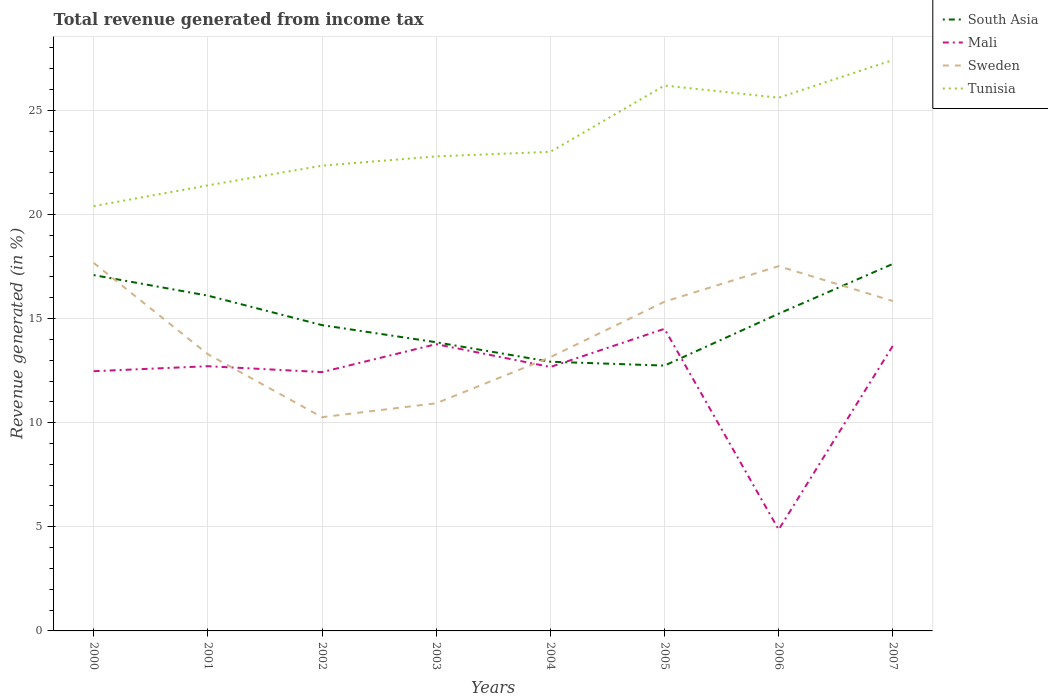Is the number of lines equal to the number of legend labels?
Keep it short and to the point. Yes. Across all years, what is the maximum total revenue generated in Sweden?
Make the answer very short. 10.26. What is the total total revenue generated in Tunisia in the graph?
Your answer should be compact. -1.81. What is the difference between the highest and the second highest total revenue generated in Mali?
Your response must be concise. 9.64. Is the total revenue generated in Tunisia strictly greater than the total revenue generated in Mali over the years?
Your answer should be very brief. No. How many lines are there?
Ensure brevity in your answer.  4. How many years are there in the graph?
Offer a very short reply. 8. What is the difference between two consecutive major ticks on the Y-axis?
Your answer should be compact. 5. Are the values on the major ticks of Y-axis written in scientific E-notation?
Offer a very short reply. No. Does the graph contain any zero values?
Ensure brevity in your answer.  No. Where does the legend appear in the graph?
Keep it short and to the point. Top right. What is the title of the graph?
Offer a terse response. Total revenue generated from income tax. Does "Spain" appear as one of the legend labels in the graph?
Keep it short and to the point. No. What is the label or title of the X-axis?
Ensure brevity in your answer.  Years. What is the label or title of the Y-axis?
Ensure brevity in your answer.  Revenue generated (in %). What is the Revenue generated (in %) of South Asia in 2000?
Your answer should be compact. 17.09. What is the Revenue generated (in %) of Mali in 2000?
Give a very brief answer. 12.47. What is the Revenue generated (in %) in Sweden in 2000?
Provide a succinct answer. 17.67. What is the Revenue generated (in %) of Tunisia in 2000?
Keep it short and to the point. 20.4. What is the Revenue generated (in %) of South Asia in 2001?
Offer a very short reply. 16.1. What is the Revenue generated (in %) of Mali in 2001?
Your answer should be very brief. 12.71. What is the Revenue generated (in %) in Sweden in 2001?
Provide a succinct answer. 13.29. What is the Revenue generated (in %) in Tunisia in 2001?
Make the answer very short. 21.39. What is the Revenue generated (in %) of South Asia in 2002?
Give a very brief answer. 14.68. What is the Revenue generated (in %) in Mali in 2002?
Make the answer very short. 12.43. What is the Revenue generated (in %) in Sweden in 2002?
Your answer should be very brief. 10.26. What is the Revenue generated (in %) of Tunisia in 2002?
Your response must be concise. 22.34. What is the Revenue generated (in %) of South Asia in 2003?
Ensure brevity in your answer.  13.86. What is the Revenue generated (in %) of Mali in 2003?
Give a very brief answer. 13.77. What is the Revenue generated (in %) in Sweden in 2003?
Give a very brief answer. 10.93. What is the Revenue generated (in %) of Tunisia in 2003?
Your answer should be very brief. 22.79. What is the Revenue generated (in %) of South Asia in 2004?
Make the answer very short. 12.93. What is the Revenue generated (in %) of Mali in 2004?
Provide a succinct answer. 12.67. What is the Revenue generated (in %) in Sweden in 2004?
Your answer should be very brief. 13.14. What is the Revenue generated (in %) in Tunisia in 2004?
Offer a very short reply. 23.01. What is the Revenue generated (in %) in South Asia in 2005?
Your answer should be compact. 12.74. What is the Revenue generated (in %) in Mali in 2005?
Offer a very short reply. 14.51. What is the Revenue generated (in %) of Sweden in 2005?
Your answer should be compact. 15.81. What is the Revenue generated (in %) in Tunisia in 2005?
Keep it short and to the point. 26.19. What is the Revenue generated (in %) in South Asia in 2006?
Ensure brevity in your answer.  15.23. What is the Revenue generated (in %) in Mali in 2006?
Provide a succinct answer. 4.87. What is the Revenue generated (in %) of Sweden in 2006?
Make the answer very short. 17.52. What is the Revenue generated (in %) in Tunisia in 2006?
Ensure brevity in your answer.  25.61. What is the Revenue generated (in %) of South Asia in 2007?
Make the answer very short. 17.62. What is the Revenue generated (in %) of Mali in 2007?
Offer a terse response. 13.69. What is the Revenue generated (in %) in Sweden in 2007?
Give a very brief answer. 15.84. What is the Revenue generated (in %) of Tunisia in 2007?
Give a very brief answer. 27.41. Across all years, what is the maximum Revenue generated (in %) in South Asia?
Ensure brevity in your answer.  17.62. Across all years, what is the maximum Revenue generated (in %) in Mali?
Provide a succinct answer. 14.51. Across all years, what is the maximum Revenue generated (in %) of Sweden?
Provide a short and direct response. 17.67. Across all years, what is the maximum Revenue generated (in %) of Tunisia?
Keep it short and to the point. 27.41. Across all years, what is the minimum Revenue generated (in %) in South Asia?
Your answer should be compact. 12.74. Across all years, what is the minimum Revenue generated (in %) in Mali?
Offer a terse response. 4.87. Across all years, what is the minimum Revenue generated (in %) of Sweden?
Your answer should be very brief. 10.26. Across all years, what is the minimum Revenue generated (in %) of Tunisia?
Keep it short and to the point. 20.4. What is the total Revenue generated (in %) of South Asia in the graph?
Give a very brief answer. 120.26. What is the total Revenue generated (in %) of Mali in the graph?
Make the answer very short. 97.12. What is the total Revenue generated (in %) in Sweden in the graph?
Offer a very short reply. 114.47. What is the total Revenue generated (in %) in Tunisia in the graph?
Offer a terse response. 189.14. What is the difference between the Revenue generated (in %) of South Asia in 2000 and that in 2001?
Your answer should be compact. 0.99. What is the difference between the Revenue generated (in %) of Mali in 2000 and that in 2001?
Provide a short and direct response. -0.24. What is the difference between the Revenue generated (in %) in Sweden in 2000 and that in 2001?
Your response must be concise. 4.38. What is the difference between the Revenue generated (in %) in Tunisia in 2000 and that in 2001?
Keep it short and to the point. -0.99. What is the difference between the Revenue generated (in %) of South Asia in 2000 and that in 2002?
Your response must be concise. 2.4. What is the difference between the Revenue generated (in %) in Mali in 2000 and that in 2002?
Keep it short and to the point. 0.04. What is the difference between the Revenue generated (in %) in Sweden in 2000 and that in 2002?
Make the answer very short. 7.41. What is the difference between the Revenue generated (in %) of Tunisia in 2000 and that in 2002?
Offer a very short reply. -1.94. What is the difference between the Revenue generated (in %) of South Asia in 2000 and that in 2003?
Provide a succinct answer. 3.23. What is the difference between the Revenue generated (in %) of Mali in 2000 and that in 2003?
Provide a succinct answer. -1.3. What is the difference between the Revenue generated (in %) in Sweden in 2000 and that in 2003?
Your response must be concise. 6.74. What is the difference between the Revenue generated (in %) of Tunisia in 2000 and that in 2003?
Your response must be concise. -2.39. What is the difference between the Revenue generated (in %) of South Asia in 2000 and that in 2004?
Your answer should be very brief. 4.16. What is the difference between the Revenue generated (in %) in Mali in 2000 and that in 2004?
Give a very brief answer. -0.2. What is the difference between the Revenue generated (in %) of Sweden in 2000 and that in 2004?
Ensure brevity in your answer.  4.53. What is the difference between the Revenue generated (in %) in Tunisia in 2000 and that in 2004?
Provide a succinct answer. -2.6. What is the difference between the Revenue generated (in %) in South Asia in 2000 and that in 2005?
Your response must be concise. 4.35. What is the difference between the Revenue generated (in %) of Mali in 2000 and that in 2005?
Your answer should be compact. -2.04. What is the difference between the Revenue generated (in %) in Sweden in 2000 and that in 2005?
Provide a short and direct response. 1.86. What is the difference between the Revenue generated (in %) of Tunisia in 2000 and that in 2005?
Provide a succinct answer. -5.79. What is the difference between the Revenue generated (in %) of South Asia in 2000 and that in 2006?
Make the answer very short. 1.85. What is the difference between the Revenue generated (in %) in Mali in 2000 and that in 2006?
Make the answer very short. 7.61. What is the difference between the Revenue generated (in %) in Sweden in 2000 and that in 2006?
Provide a succinct answer. 0.16. What is the difference between the Revenue generated (in %) of Tunisia in 2000 and that in 2006?
Your answer should be compact. -5.2. What is the difference between the Revenue generated (in %) in South Asia in 2000 and that in 2007?
Make the answer very short. -0.54. What is the difference between the Revenue generated (in %) of Mali in 2000 and that in 2007?
Provide a succinct answer. -1.22. What is the difference between the Revenue generated (in %) in Sweden in 2000 and that in 2007?
Provide a succinct answer. 1.83. What is the difference between the Revenue generated (in %) in Tunisia in 2000 and that in 2007?
Give a very brief answer. -7.01. What is the difference between the Revenue generated (in %) of South Asia in 2001 and that in 2002?
Your answer should be compact. 1.42. What is the difference between the Revenue generated (in %) in Mali in 2001 and that in 2002?
Give a very brief answer. 0.28. What is the difference between the Revenue generated (in %) of Sweden in 2001 and that in 2002?
Give a very brief answer. 3.03. What is the difference between the Revenue generated (in %) of Tunisia in 2001 and that in 2002?
Ensure brevity in your answer.  -0.95. What is the difference between the Revenue generated (in %) of South Asia in 2001 and that in 2003?
Keep it short and to the point. 2.24. What is the difference between the Revenue generated (in %) of Mali in 2001 and that in 2003?
Ensure brevity in your answer.  -1.06. What is the difference between the Revenue generated (in %) of Sweden in 2001 and that in 2003?
Give a very brief answer. 2.36. What is the difference between the Revenue generated (in %) of Tunisia in 2001 and that in 2003?
Your answer should be very brief. -1.39. What is the difference between the Revenue generated (in %) of South Asia in 2001 and that in 2004?
Offer a very short reply. 3.17. What is the difference between the Revenue generated (in %) of Mali in 2001 and that in 2004?
Your answer should be very brief. 0.04. What is the difference between the Revenue generated (in %) of Sweden in 2001 and that in 2004?
Provide a succinct answer. 0.14. What is the difference between the Revenue generated (in %) of Tunisia in 2001 and that in 2004?
Give a very brief answer. -1.61. What is the difference between the Revenue generated (in %) of South Asia in 2001 and that in 2005?
Offer a terse response. 3.36. What is the difference between the Revenue generated (in %) of Mali in 2001 and that in 2005?
Give a very brief answer. -1.8. What is the difference between the Revenue generated (in %) of Sweden in 2001 and that in 2005?
Give a very brief answer. -2.52. What is the difference between the Revenue generated (in %) in Tunisia in 2001 and that in 2005?
Offer a very short reply. -4.79. What is the difference between the Revenue generated (in %) of South Asia in 2001 and that in 2006?
Keep it short and to the point. 0.87. What is the difference between the Revenue generated (in %) of Mali in 2001 and that in 2006?
Make the answer very short. 7.84. What is the difference between the Revenue generated (in %) of Sweden in 2001 and that in 2006?
Give a very brief answer. -4.23. What is the difference between the Revenue generated (in %) of Tunisia in 2001 and that in 2006?
Your answer should be very brief. -4.21. What is the difference between the Revenue generated (in %) in South Asia in 2001 and that in 2007?
Give a very brief answer. -1.52. What is the difference between the Revenue generated (in %) of Mali in 2001 and that in 2007?
Give a very brief answer. -0.98. What is the difference between the Revenue generated (in %) of Sweden in 2001 and that in 2007?
Provide a succinct answer. -2.55. What is the difference between the Revenue generated (in %) in Tunisia in 2001 and that in 2007?
Offer a terse response. -6.02. What is the difference between the Revenue generated (in %) of South Asia in 2002 and that in 2003?
Your answer should be very brief. 0.82. What is the difference between the Revenue generated (in %) of Mali in 2002 and that in 2003?
Offer a very short reply. -1.34. What is the difference between the Revenue generated (in %) of Sweden in 2002 and that in 2003?
Your response must be concise. -0.67. What is the difference between the Revenue generated (in %) in Tunisia in 2002 and that in 2003?
Your response must be concise. -0.45. What is the difference between the Revenue generated (in %) in South Asia in 2002 and that in 2004?
Your response must be concise. 1.76. What is the difference between the Revenue generated (in %) in Mali in 2002 and that in 2004?
Your answer should be very brief. -0.25. What is the difference between the Revenue generated (in %) in Sweden in 2002 and that in 2004?
Your answer should be compact. -2.88. What is the difference between the Revenue generated (in %) of Tunisia in 2002 and that in 2004?
Offer a terse response. -0.66. What is the difference between the Revenue generated (in %) in South Asia in 2002 and that in 2005?
Offer a terse response. 1.94. What is the difference between the Revenue generated (in %) of Mali in 2002 and that in 2005?
Offer a very short reply. -2.08. What is the difference between the Revenue generated (in %) in Sweden in 2002 and that in 2005?
Keep it short and to the point. -5.55. What is the difference between the Revenue generated (in %) in Tunisia in 2002 and that in 2005?
Offer a terse response. -3.85. What is the difference between the Revenue generated (in %) in South Asia in 2002 and that in 2006?
Your response must be concise. -0.55. What is the difference between the Revenue generated (in %) in Mali in 2002 and that in 2006?
Offer a terse response. 7.56. What is the difference between the Revenue generated (in %) in Sweden in 2002 and that in 2006?
Offer a very short reply. -7.25. What is the difference between the Revenue generated (in %) in Tunisia in 2002 and that in 2006?
Provide a short and direct response. -3.26. What is the difference between the Revenue generated (in %) in South Asia in 2002 and that in 2007?
Your answer should be compact. -2.94. What is the difference between the Revenue generated (in %) in Mali in 2002 and that in 2007?
Ensure brevity in your answer.  -1.26. What is the difference between the Revenue generated (in %) in Sweden in 2002 and that in 2007?
Your answer should be compact. -5.58. What is the difference between the Revenue generated (in %) in Tunisia in 2002 and that in 2007?
Your answer should be compact. -5.07. What is the difference between the Revenue generated (in %) in South Asia in 2003 and that in 2004?
Offer a terse response. 0.93. What is the difference between the Revenue generated (in %) in Mali in 2003 and that in 2004?
Make the answer very short. 1.1. What is the difference between the Revenue generated (in %) in Sweden in 2003 and that in 2004?
Ensure brevity in your answer.  -2.21. What is the difference between the Revenue generated (in %) in Tunisia in 2003 and that in 2004?
Your response must be concise. -0.22. What is the difference between the Revenue generated (in %) in South Asia in 2003 and that in 2005?
Ensure brevity in your answer.  1.12. What is the difference between the Revenue generated (in %) in Mali in 2003 and that in 2005?
Make the answer very short. -0.74. What is the difference between the Revenue generated (in %) of Sweden in 2003 and that in 2005?
Offer a terse response. -4.88. What is the difference between the Revenue generated (in %) of Tunisia in 2003 and that in 2005?
Give a very brief answer. -3.4. What is the difference between the Revenue generated (in %) of South Asia in 2003 and that in 2006?
Offer a very short reply. -1.37. What is the difference between the Revenue generated (in %) of Mali in 2003 and that in 2006?
Give a very brief answer. 8.9. What is the difference between the Revenue generated (in %) of Sweden in 2003 and that in 2006?
Your response must be concise. -6.59. What is the difference between the Revenue generated (in %) of Tunisia in 2003 and that in 2006?
Ensure brevity in your answer.  -2.82. What is the difference between the Revenue generated (in %) of South Asia in 2003 and that in 2007?
Provide a succinct answer. -3.76. What is the difference between the Revenue generated (in %) of Mali in 2003 and that in 2007?
Ensure brevity in your answer.  0.08. What is the difference between the Revenue generated (in %) in Sweden in 2003 and that in 2007?
Make the answer very short. -4.91. What is the difference between the Revenue generated (in %) of Tunisia in 2003 and that in 2007?
Offer a terse response. -4.63. What is the difference between the Revenue generated (in %) in South Asia in 2004 and that in 2005?
Your answer should be compact. 0.19. What is the difference between the Revenue generated (in %) of Mali in 2004 and that in 2005?
Your answer should be very brief. -1.83. What is the difference between the Revenue generated (in %) of Sweden in 2004 and that in 2005?
Offer a terse response. -2.66. What is the difference between the Revenue generated (in %) of Tunisia in 2004 and that in 2005?
Provide a short and direct response. -3.18. What is the difference between the Revenue generated (in %) in South Asia in 2004 and that in 2006?
Your response must be concise. -2.31. What is the difference between the Revenue generated (in %) in Mali in 2004 and that in 2006?
Your response must be concise. 7.81. What is the difference between the Revenue generated (in %) in Sweden in 2004 and that in 2006?
Provide a succinct answer. -4.37. What is the difference between the Revenue generated (in %) in South Asia in 2004 and that in 2007?
Your answer should be compact. -4.7. What is the difference between the Revenue generated (in %) of Mali in 2004 and that in 2007?
Your response must be concise. -1.02. What is the difference between the Revenue generated (in %) in Sweden in 2004 and that in 2007?
Keep it short and to the point. -2.69. What is the difference between the Revenue generated (in %) in Tunisia in 2004 and that in 2007?
Your answer should be very brief. -4.41. What is the difference between the Revenue generated (in %) of South Asia in 2005 and that in 2006?
Your response must be concise. -2.49. What is the difference between the Revenue generated (in %) of Mali in 2005 and that in 2006?
Ensure brevity in your answer.  9.64. What is the difference between the Revenue generated (in %) in Sweden in 2005 and that in 2006?
Offer a terse response. -1.71. What is the difference between the Revenue generated (in %) of Tunisia in 2005 and that in 2006?
Your answer should be very brief. 0.58. What is the difference between the Revenue generated (in %) in South Asia in 2005 and that in 2007?
Your response must be concise. -4.88. What is the difference between the Revenue generated (in %) in Mali in 2005 and that in 2007?
Offer a terse response. 0.82. What is the difference between the Revenue generated (in %) of Sweden in 2005 and that in 2007?
Give a very brief answer. -0.03. What is the difference between the Revenue generated (in %) of Tunisia in 2005 and that in 2007?
Keep it short and to the point. -1.22. What is the difference between the Revenue generated (in %) in South Asia in 2006 and that in 2007?
Make the answer very short. -2.39. What is the difference between the Revenue generated (in %) of Mali in 2006 and that in 2007?
Provide a succinct answer. -8.82. What is the difference between the Revenue generated (in %) in Sweden in 2006 and that in 2007?
Offer a very short reply. 1.68. What is the difference between the Revenue generated (in %) of Tunisia in 2006 and that in 2007?
Provide a short and direct response. -1.81. What is the difference between the Revenue generated (in %) in South Asia in 2000 and the Revenue generated (in %) in Mali in 2001?
Offer a terse response. 4.38. What is the difference between the Revenue generated (in %) in South Asia in 2000 and the Revenue generated (in %) in Sweden in 2001?
Provide a succinct answer. 3.8. What is the difference between the Revenue generated (in %) of South Asia in 2000 and the Revenue generated (in %) of Tunisia in 2001?
Keep it short and to the point. -4.31. What is the difference between the Revenue generated (in %) in Mali in 2000 and the Revenue generated (in %) in Sweden in 2001?
Offer a very short reply. -0.82. What is the difference between the Revenue generated (in %) of Mali in 2000 and the Revenue generated (in %) of Tunisia in 2001?
Your response must be concise. -8.92. What is the difference between the Revenue generated (in %) of Sweden in 2000 and the Revenue generated (in %) of Tunisia in 2001?
Provide a succinct answer. -3.72. What is the difference between the Revenue generated (in %) of South Asia in 2000 and the Revenue generated (in %) of Mali in 2002?
Offer a terse response. 4.66. What is the difference between the Revenue generated (in %) of South Asia in 2000 and the Revenue generated (in %) of Sweden in 2002?
Keep it short and to the point. 6.82. What is the difference between the Revenue generated (in %) in South Asia in 2000 and the Revenue generated (in %) in Tunisia in 2002?
Make the answer very short. -5.25. What is the difference between the Revenue generated (in %) of Mali in 2000 and the Revenue generated (in %) of Sweden in 2002?
Keep it short and to the point. 2.21. What is the difference between the Revenue generated (in %) in Mali in 2000 and the Revenue generated (in %) in Tunisia in 2002?
Your answer should be very brief. -9.87. What is the difference between the Revenue generated (in %) in Sweden in 2000 and the Revenue generated (in %) in Tunisia in 2002?
Your answer should be compact. -4.67. What is the difference between the Revenue generated (in %) of South Asia in 2000 and the Revenue generated (in %) of Mali in 2003?
Make the answer very short. 3.32. What is the difference between the Revenue generated (in %) in South Asia in 2000 and the Revenue generated (in %) in Sweden in 2003?
Offer a very short reply. 6.16. What is the difference between the Revenue generated (in %) in South Asia in 2000 and the Revenue generated (in %) in Tunisia in 2003?
Your response must be concise. -5.7. What is the difference between the Revenue generated (in %) of Mali in 2000 and the Revenue generated (in %) of Sweden in 2003?
Your answer should be compact. 1.54. What is the difference between the Revenue generated (in %) in Mali in 2000 and the Revenue generated (in %) in Tunisia in 2003?
Your response must be concise. -10.32. What is the difference between the Revenue generated (in %) in Sweden in 2000 and the Revenue generated (in %) in Tunisia in 2003?
Make the answer very short. -5.11. What is the difference between the Revenue generated (in %) of South Asia in 2000 and the Revenue generated (in %) of Mali in 2004?
Make the answer very short. 4.41. What is the difference between the Revenue generated (in %) in South Asia in 2000 and the Revenue generated (in %) in Sweden in 2004?
Give a very brief answer. 3.94. What is the difference between the Revenue generated (in %) in South Asia in 2000 and the Revenue generated (in %) in Tunisia in 2004?
Make the answer very short. -5.92. What is the difference between the Revenue generated (in %) of Mali in 2000 and the Revenue generated (in %) of Sweden in 2004?
Provide a short and direct response. -0.67. What is the difference between the Revenue generated (in %) of Mali in 2000 and the Revenue generated (in %) of Tunisia in 2004?
Ensure brevity in your answer.  -10.53. What is the difference between the Revenue generated (in %) in Sweden in 2000 and the Revenue generated (in %) in Tunisia in 2004?
Provide a short and direct response. -5.33. What is the difference between the Revenue generated (in %) in South Asia in 2000 and the Revenue generated (in %) in Mali in 2005?
Your answer should be compact. 2.58. What is the difference between the Revenue generated (in %) in South Asia in 2000 and the Revenue generated (in %) in Sweden in 2005?
Keep it short and to the point. 1.28. What is the difference between the Revenue generated (in %) of South Asia in 2000 and the Revenue generated (in %) of Tunisia in 2005?
Give a very brief answer. -9.1. What is the difference between the Revenue generated (in %) in Mali in 2000 and the Revenue generated (in %) in Sweden in 2005?
Offer a very short reply. -3.34. What is the difference between the Revenue generated (in %) of Mali in 2000 and the Revenue generated (in %) of Tunisia in 2005?
Provide a short and direct response. -13.72. What is the difference between the Revenue generated (in %) of Sweden in 2000 and the Revenue generated (in %) of Tunisia in 2005?
Ensure brevity in your answer.  -8.52. What is the difference between the Revenue generated (in %) of South Asia in 2000 and the Revenue generated (in %) of Mali in 2006?
Offer a very short reply. 12.22. What is the difference between the Revenue generated (in %) in South Asia in 2000 and the Revenue generated (in %) in Sweden in 2006?
Your response must be concise. -0.43. What is the difference between the Revenue generated (in %) in South Asia in 2000 and the Revenue generated (in %) in Tunisia in 2006?
Give a very brief answer. -8.52. What is the difference between the Revenue generated (in %) in Mali in 2000 and the Revenue generated (in %) in Sweden in 2006?
Provide a succinct answer. -5.04. What is the difference between the Revenue generated (in %) of Mali in 2000 and the Revenue generated (in %) of Tunisia in 2006?
Offer a terse response. -13.13. What is the difference between the Revenue generated (in %) of Sweden in 2000 and the Revenue generated (in %) of Tunisia in 2006?
Give a very brief answer. -7.93. What is the difference between the Revenue generated (in %) in South Asia in 2000 and the Revenue generated (in %) in Mali in 2007?
Ensure brevity in your answer.  3.4. What is the difference between the Revenue generated (in %) in South Asia in 2000 and the Revenue generated (in %) in Sweden in 2007?
Your answer should be compact. 1.25. What is the difference between the Revenue generated (in %) in South Asia in 2000 and the Revenue generated (in %) in Tunisia in 2007?
Offer a terse response. -10.33. What is the difference between the Revenue generated (in %) in Mali in 2000 and the Revenue generated (in %) in Sweden in 2007?
Give a very brief answer. -3.37. What is the difference between the Revenue generated (in %) in Mali in 2000 and the Revenue generated (in %) in Tunisia in 2007?
Keep it short and to the point. -14.94. What is the difference between the Revenue generated (in %) of Sweden in 2000 and the Revenue generated (in %) of Tunisia in 2007?
Make the answer very short. -9.74. What is the difference between the Revenue generated (in %) of South Asia in 2001 and the Revenue generated (in %) of Mali in 2002?
Offer a terse response. 3.67. What is the difference between the Revenue generated (in %) in South Asia in 2001 and the Revenue generated (in %) in Sweden in 2002?
Your answer should be compact. 5.84. What is the difference between the Revenue generated (in %) of South Asia in 2001 and the Revenue generated (in %) of Tunisia in 2002?
Keep it short and to the point. -6.24. What is the difference between the Revenue generated (in %) in Mali in 2001 and the Revenue generated (in %) in Sweden in 2002?
Offer a terse response. 2.45. What is the difference between the Revenue generated (in %) of Mali in 2001 and the Revenue generated (in %) of Tunisia in 2002?
Keep it short and to the point. -9.63. What is the difference between the Revenue generated (in %) of Sweden in 2001 and the Revenue generated (in %) of Tunisia in 2002?
Provide a short and direct response. -9.05. What is the difference between the Revenue generated (in %) in South Asia in 2001 and the Revenue generated (in %) in Mali in 2003?
Your answer should be compact. 2.33. What is the difference between the Revenue generated (in %) in South Asia in 2001 and the Revenue generated (in %) in Sweden in 2003?
Give a very brief answer. 5.17. What is the difference between the Revenue generated (in %) in South Asia in 2001 and the Revenue generated (in %) in Tunisia in 2003?
Your answer should be compact. -6.69. What is the difference between the Revenue generated (in %) in Mali in 2001 and the Revenue generated (in %) in Sweden in 2003?
Your answer should be compact. 1.78. What is the difference between the Revenue generated (in %) of Mali in 2001 and the Revenue generated (in %) of Tunisia in 2003?
Your answer should be very brief. -10.08. What is the difference between the Revenue generated (in %) in Sweden in 2001 and the Revenue generated (in %) in Tunisia in 2003?
Your response must be concise. -9.5. What is the difference between the Revenue generated (in %) of South Asia in 2001 and the Revenue generated (in %) of Mali in 2004?
Your response must be concise. 3.43. What is the difference between the Revenue generated (in %) in South Asia in 2001 and the Revenue generated (in %) in Sweden in 2004?
Give a very brief answer. 2.96. What is the difference between the Revenue generated (in %) in South Asia in 2001 and the Revenue generated (in %) in Tunisia in 2004?
Ensure brevity in your answer.  -6.91. What is the difference between the Revenue generated (in %) of Mali in 2001 and the Revenue generated (in %) of Sweden in 2004?
Make the answer very short. -0.43. What is the difference between the Revenue generated (in %) in Mali in 2001 and the Revenue generated (in %) in Tunisia in 2004?
Make the answer very short. -10.29. What is the difference between the Revenue generated (in %) of Sweden in 2001 and the Revenue generated (in %) of Tunisia in 2004?
Your response must be concise. -9.72. What is the difference between the Revenue generated (in %) in South Asia in 2001 and the Revenue generated (in %) in Mali in 2005?
Offer a terse response. 1.59. What is the difference between the Revenue generated (in %) of South Asia in 2001 and the Revenue generated (in %) of Sweden in 2005?
Your answer should be very brief. 0.29. What is the difference between the Revenue generated (in %) in South Asia in 2001 and the Revenue generated (in %) in Tunisia in 2005?
Provide a succinct answer. -10.09. What is the difference between the Revenue generated (in %) of Mali in 2001 and the Revenue generated (in %) of Sweden in 2005?
Offer a terse response. -3.1. What is the difference between the Revenue generated (in %) in Mali in 2001 and the Revenue generated (in %) in Tunisia in 2005?
Ensure brevity in your answer.  -13.48. What is the difference between the Revenue generated (in %) of Sweden in 2001 and the Revenue generated (in %) of Tunisia in 2005?
Give a very brief answer. -12.9. What is the difference between the Revenue generated (in %) in South Asia in 2001 and the Revenue generated (in %) in Mali in 2006?
Your answer should be very brief. 11.23. What is the difference between the Revenue generated (in %) in South Asia in 2001 and the Revenue generated (in %) in Sweden in 2006?
Your response must be concise. -1.42. What is the difference between the Revenue generated (in %) in South Asia in 2001 and the Revenue generated (in %) in Tunisia in 2006?
Offer a terse response. -9.51. What is the difference between the Revenue generated (in %) of Mali in 2001 and the Revenue generated (in %) of Sweden in 2006?
Give a very brief answer. -4.81. What is the difference between the Revenue generated (in %) of Mali in 2001 and the Revenue generated (in %) of Tunisia in 2006?
Your answer should be very brief. -12.89. What is the difference between the Revenue generated (in %) in Sweden in 2001 and the Revenue generated (in %) in Tunisia in 2006?
Give a very brief answer. -12.32. What is the difference between the Revenue generated (in %) of South Asia in 2001 and the Revenue generated (in %) of Mali in 2007?
Your answer should be very brief. 2.41. What is the difference between the Revenue generated (in %) of South Asia in 2001 and the Revenue generated (in %) of Sweden in 2007?
Your answer should be compact. 0.26. What is the difference between the Revenue generated (in %) in South Asia in 2001 and the Revenue generated (in %) in Tunisia in 2007?
Ensure brevity in your answer.  -11.31. What is the difference between the Revenue generated (in %) of Mali in 2001 and the Revenue generated (in %) of Sweden in 2007?
Your response must be concise. -3.13. What is the difference between the Revenue generated (in %) in Mali in 2001 and the Revenue generated (in %) in Tunisia in 2007?
Give a very brief answer. -14.7. What is the difference between the Revenue generated (in %) in Sweden in 2001 and the Revenue generated (in %) in Tunisia in 2007?
Ensure brevity in your answer.  -14.12. What is the difference between the Revenue generated (in %) in South Asia in 2002 and the Revenue generated (in %) in Mali in 2003?
Your response must be concise. 0.92. What is the difference between the Revenue generated (in %) in South Asia in 2002 and the Revenue generated (in %) in Sweden in 2003?
Your response must be concise. 3.75. What is the difference between the Revenue generated (in %) of South Asia in 2002 and the Revenue generated (in %) of Tunisia in 2003?
Your response must be concise. -8.1. What is the difference between the Revenue generated (in %) in Mali in 2002 and the Revenue generated (in %) in Sweden in 2003?
Provide a short and direct response. 1.5. What is the difference between the Revenue generated (in %) in Mali in 2002 and the Revenue generated (in %) in Tunisia in 2003?
Your response must be concise. -10.36. What is the difference between the Revenue generated (in %) of Sweden in 2002 and the Revenue generated (in %) of Tunisia in 2003?
Provide a short and direct response. -12.52. What is the difference between the Revenue generated (in %) in South Asia in 2002 and the Revenue generated (in %) in Mali in 2004?
Offer a very short reply. 2.01. What is the difference between the Revenue generated (in %) in South Asia in 2002 and the Revenue generated (in %) in Sweden in 2004?
Your answer should be compact. 1.54. What is the difference between the Revenue generated (in %) in South Asia in 2002 and the Revenue generated (in %) in Tunisia in 2004?
Provide a short and direct response. -8.32. What is the difference between the Revenue generated (in %) of Mali in 2002 and the Revenue generated (in %) of Sweden in 2004?
Offer a very short reply. -0.72. What is the difference between the Revenue generated (in %) in Mali in 2002 and the Revenue generated (in %) in Tunisia in 2004?
Ensure brevity in your answer.  -10.58. What is the difference between the Revenue generated (in %) of Sweden in 2002 and the Revenue generated (in %) of Tunisia in 2004?
Give a very brief answer. -12.74. What is the difference between the Revenue generated (in %) of South Asia in 2002 and the Revenue generated (in %) of Mali in 2005?
Provide a succinct answer. 0.18. What is the difference between the Revenue generated (in %) of South Asia in 2002 and the Revenue generated (in %) of Sweden in 2005?
Give a very brief answer. -1.12. What is the difference between the Revenue generated (in %) in South Asia in 2002 and the Revenue generated (in %) in Tunisia in 2005?
Your answer should be compact. -11.5. What is the difference between the Revenue generated (in %) in Mali in 2002 and the Revenue generated (in %) in Sweden in 2005?
Offer a terse response. -3.38. What is the difference between the Revenue generated (in %) in Mali in 2002 and the Revenue generated (in %) in Tunisia in 2005?
Give a very brief answer. -13.76. What is the difference between the Revenue generated (in %) in Sweden in 2002 and the Revenue generated (in %) in Tunisia in 2005?
Offer a very short reply. -15.93. What is the difference between the Revenue generated (in %) in South Asia in 2002 and the Revenue generated (in %) in Mali in 2006?
Provide a succinct answer. 9.82. What is the difference between the Revenue generated (in %) of South Asia in 2002 and the Revenue generated (in %) of Sweden in 2006?
Keep it short and to the point. -2.83. What is the difference between the Revenue generated (in %) of South Asia in 2002 and the Revenue generated (in %) of Tunisia in 2006?
Your answer should be compact. -10.92. What is the difference between the Revenue generated (in %) of Mali in 2002 and the Revenue generated (in %) of Sweden in 2006?
Offer a terse response. -5.09. What is the difference between the Revenue generated (in %) of Mali in 2002 and the Revenue generated (in %) of Tunisia in 2006?
Make the answer very short. -13.18. What is the difference between the Revenue generated (in %) of Sweden in 2002 and the Revenue generated (in %) of Tunisia in 2006?
Your response must be concise. -15.34. What is the difference between the Revenue generated (in %) in South Asia in 2002 and the Revenue generated (in %) in Mali in 2007?
Provide a succinct answer. 0.99. What is the difference between the Revenue generated (in %) in South Asia in 2002 and the Revenue generated (in %) in Sweden in 2007?
Your response must be concise. -1.15. What is the difference between the Revenue generated (in %) in South Asia in 2002 and the Revenue generated (in %) in Tunisia in 2007?
Keep it short and to the point. -12.73. What is the difference between the Revenue generated (in %) in Mali in 2002 and the Revenue generated (in %) in Sweden in 2007?
Your response must be concise. -3.41. What is the difference between the Revenue generated (in %) of Mali in 2002 and the Revenue generated (in %) of Tunisia in 2007?
Offer a very short reply. -14.99. What is the difference between the Revenue generated (in %) of Sweden in 2002 and the Revenue generated (in %) of Tunisia in 2007?
Your answer should be very brief. -17.15. What is the difference between the Revenue generated (in %) in South Asia in 2003 and the Revenue generated (in %) in Mali in 2004?
Make the answer very short. 1.19. What is the difference between the Revenue generated (in %) in South Asia in 2003 and the Revenue generated (in %) in Sweden in 2004?
Offer a terse response. 0.72. What is the difference between the Revenue generated (in %) in South Asia in 2003 and the Revenue generated (in %) in Tunisia in 2004?
Offer a very short reply. -9.14. What is the difference between the Revenue generated (in %) of Mali in 2003 and the Revenue generated (in %) of Sweden in 2004?
Give a very brief answer. 0.62. What is the difference between the Revenue generated (in %) of Mali in 2003 and the Revenue generated (in %) of Tunisia in 2004?
Your response must be concise. -9.24. What is the difference between the Revenue generated (in %) in Sweden in 2003 and the Revenue generated (in %) in Tunisia in 2004?
Keep it short and to the point. -12.07. What is the difference between the Revenue generated (in %) of South Asia in 2003 and the Revenue generated (in %) of Mali in 2005?
Your answer should be compact. -0.65. What is the difference between the Revenue generated (in %) of South Asia in 2003 and the Revenue generated (in %) of Sweden in 2005?
Provide a short and direct response. -1.95. What is the difference between the Revenue generated (in %) in South Asia in 2003 and the Revenue generated (in %) in Tunisia in 2005?
Your answer should be very brief. -12.33. What is the difference between the Revenue generated (in %) of Mali in 2003 and the Revenue generated (in %) of Sweden in 2005?
Your response must be concise. -2.04. What is the difference between the Revenue generated (in %) of Mali in 2003 and the Revenue generated (in %) of Tunisia in 2005?
Make the answer very short. -12.42. What is the difference between the Revenue generated (in %) in Sweden in 2003 and the Revenue generated (in %) in Tunisia in 2005?
Keep it short and to the point. -15.26. What is the difference between the Revenue generated (in %) of South Asia in 2003 and the Revenue generated (in %) of Mali in 2006?
Give a very brief answer. 8.99. What is the difference between the Revenue generated (in %) of South Asia in 2003 and the Revenue generated (in %) of Sweden in 2006?
Your response must be concise. -3.66. What is the difference between the Revenue generated (in %) in South Asia in 2003 and the Revenue generated (in %) in Tunisia in 2006?
Provide a succinct answer. -11.74. What is the difference between the Revenue generated (in %) in Mali in 2003 and the Revenue generated (in %) in Sweden in 2006?
Keep it short and to the point. -3.75. What is the difference between the Revenue generated (in %) of Mali in 2003 and the Revenue generated (in %) of Tunisia in 2006?
Your response must be concise. -11.84. What is the difference between the Revenue generated (in %) of Sweden in 2003 and the Revenue generated (in %) of Tunisia in 2006?
Provide a short and direct response. -14.67. What is the difference between the Revenue generated (in %) of South Asia in 2003 and the Revenue generated (in %) of Mali in 2007?
Offer a very short reply. 0.17. What is the difference between the Revenue generated (in %) of South Asia in 2003 and the Revenue generated (in %) of Sweden in 2007?
Provide a succinct answer. -1.98. What is the difference between the Revenue generated (in %) in South Asia in 2003 and the Revenue generated (in %) in Tunisia in 2007?
Keep it short and to the point. -13.55. What is the difference between the Revenue generated (in %) in Mali in 2003 and the Revenue generated (in %) in Sweden in 2007?
Give a very brief answer. -2.07. What is the difference between the Revenue generated (in %) of Mali in 2003 and the Revenue generated (in %) of Tunisia in 2007?
Offer a very short reply. -13.64. What is the difference between the Revenue generated (in %) in Sweden in 2003 and the Revenue generated (in %) in Tunisia in 2007?
Offer a very short reply. -16.48. What is the difference between the Revenue generated (in %) in South Asia in 2004 and the Revenue generated (in %) in Mali in 2005?
Provide a succinct answer. -1.58. What is the difference between the Revenue generated (in %) of South Asia in 2004 and the Revenue generated (in %) of Sweden in 2005?
Ensure brevity in your answer.  -2.88. What is the difference between the Revenue generated (in %) of South Asia in 2004 and the Revenue generated (in %) of Tunisia in 2005?
Give a very brief answer. -13.26. What is the difference between the Revenue generated (in %) in Mali in 2004 and the Revenue generated (in %) in Sweden in 2005?
Ensure brevity in your answer.  -3.14. What is the difference between the Revenue generated (in %) of Mali in 2004 and the Revenue generated (in %) of Tunisia in 2005?
Provide a succinct answer. -13.52. What is the difference between the Revenue generated (in %) of Sweden in 2004 and the Revenue generated (in %) of Tunisia in 2005?
Make the answer very short. -13.04. What is the difference between the Revenue generated (in %) of South Asia in 2004 and the Revenue generated (in %) of Mali in 2006?
Keep it short and to the point. 8.06. What is the difference between the Revenue generated (in %) of South Asia in 2004 and the Revenue generated (in %) of Sweden in 2006?
Your answer should be very brief. -4.59. What is the difference between the Revenue generated (in %) in South Asia in 2004 and the Revenue generated (in %) in Tunisia in 2006?
Your answer should be compact. -12.68. What is the difference between the Revenue generated (in %) of Mali in 2004 and the Revenue generated (in %) of Sweden in 2006?
Offer a very short reply. -4.84. What is the difference between the Revenue generated (in %) in Mali in 2004 and the Revenue generated (in %) in Tunisia in 2006?
Your answer should be compact. -12.93. What is the difference between the Revenue generated (in %) of Sweden in 2004 and the Revenue generated (in %) of Tunisia in 2006?
Provide a succinct answer. -12.46. What is the difference between the Revenue generated (in %) of South Asia in 2004 and the Revenue generated (in %) of Mali in 2007?
Keep it short and to the point. -0.76. What is the difference between the Revenue generated (in %) of South Asia in 2004 and the Revenue generated (in %) of Sweden in 2007?
Your response must be concise. -2.91. What is the difference between the Revenue generated (in %) of South Asia in 2004 and the Revenue generated (in %) of Tunisia in 2007?
Make the answer very short. -14.49. What is the difference between the Revenue generated (in %) of Mali in 2004 and the Revenue generated (in %) of Sweden in 2007?
Ensure brevity in your answer.  -3.17. What is the difference between the Revenue generated (in %) of Mali in 2004 and the Revenue generated (in %) of Tunisia in 2007?
Provide a short and direct response. -14.74. What is the difference between the Revenue generated (in %) in Sweden in 2004 and the Revenue generated (in %) in Tunisia in 2007?
Ensure brevity in your answer.  -14.27. What is the difference between the Revenue generated (in %) of South Asia in 2005 and the Revenue generated (in %) of Mali in 2006?
Provide a short and direct response. 7.87. What is the difference between the Revenue generated (in %) in South Asia in 2005 and the Revenue generated (in %) in Sweden in 2006?
Provide a short and direct response. -4.78. What is the difference between the Revenue generated (in %) in South Asia in 2005 and the Revenue generated (in %) in Tunisia in 2006?
Give a very brief answer. -12.86. What is the difference between the Revenue generated (in %) of Mali in 2005 and the Revenue generated (in %) of Sweden in 2006?
Keep it short and to the point. -3.01. What is the difference between the Revenue generated (in %) of Mali in 2005 and the Revenue generated (in %) of Tunisia in 2006?
Make the answer very short. -11.1. What is the difference between the Revenue generated (in %) in Sweden in 2005 and the Revenue generated (in %) in Tunisia in 2006?
Provide a short and direct response. -9.8. What is the difference between the Revenue generated (in %) of South Asia in 2005 and the Revenue generated (in %) of Mali in 2007?
Make the answer very short. -0.95. What is the difference between the Revenue generated (in %) in South Asia in 2005 and the Revenue generated (in %) in Sweden in 2007?
Provide a succinct answer. -3.1. What is the difference between the Revenue generated (in %) of South Asia in 2005 and the Revenue generated (in %) of Tunisia in 2007?
Offer a terse response. -14.67. What is the difference between the Revenue generated (in %) in Mali in 2005 and the Revenue generated (in %) in Sweden in 2007?
Give a very brief answer. -1.33. What is the difference between the Revenue generated (in %) of Mali in 2005 and the Revenue generated (in %) of Tunisia in 2007?
Give a very brief answer. -12.91. What is the difference between the Revenue generated (in %) of Sweden in 2005 and the Revenue generated (in %) of Tunisia in 2007?
Provide a short and direct response. -11.6. What is the difference between the Revenue generated (in %) of South Asia in 2006 and the Revenue generated (in %) of Mali in 2007?
Ensure brevity in your answer.  1.54. What is the difference between the Revenue generated (in %) of South Asia in 2006 and the Revenue generated (in %) of Sweden in 2007?
Provide a succinct answer. -0.61. What is the difference between the Revenue generated (in %) in South Asia in 2006 and the Revenue generated (in %) in Tunisia in 2007?
Offer a terse response. -12.18. What is the difference between the Revenue generated (in %) of Mali in 2006 and the Revenue generated (in %) of Sweden in 2007?
Offer a terse response. -10.97. What is the difference between the Revenue generated (in %) in Mali in 2006 and the Revenue generated (in %) in Tunisia in 2007?
Your response must be concise. -22.55. What is the difference between the Revenue generated (in %) of Sweden in 2006 and the Revenue generated (in %) of Tunisia in 2007?
Provide a succinct answer. -9.9. What is the average Revenue generated (in %) in South Asia per year?
Your answer should be very brief. 15.03. What is the average Revenue generated (in %) in Mali per year?
Keep it short and to the point. 12.14. What is the average Revenue generated (in %) of Sweden per year?
Provide a short and direct response. 14.31. What is the average Revenue generated (in %) of Tunisia per year?
Offer a very short reply. 23.64. In the year 2000, what is the difference between the Revenue generated (in %) of South Asia and Revenue generated (in %) of Mali?
Ensure brevity in your answer.  4.62. In the year 2000, what is the difference between the Revenue generated (in %) in South Asia and Revenue generated (in %) in Sweden?
Provide a short and direct response. -0.59. In the year 2000, what is the difference between the Revenue generated (in %) in South Asia and Revenue generated (in %) in Tunisia?
Your answer should be very brief. -3.31. In the year 2000, what is the difference between the Revenue generated (in %) of Mali and Revenue generated (in %) of Sweden?
Provide a succinct answer. -5.2. In the year 2000, what is the difference between the Revenue generated (in %) of Mali and Revenue generated (in %) of Tunisia?
Ensure brevity in your answer.  -7.93. In the year 2000, what is the difference between the Revenue generated (in %) in Sweden and Revenue generated (in %) in Tunisia?
Make the answer very short. -2.73. In the year 2001, what is the difference between the Revenue generated (in %) in South Asia and Revenue generated (in %) in Mali?
Keep it short and to the point. 3.39. In the year 2001, what is the difference between the Revenue generated (in %) in South Asia and Revenue generated (in %) in Sweden?
Your answer should be very brief. 2.81. In the year 2001, what is the difference between the Revenue generated (in %) in South Asia and Revenue generated (in %) in Tunisia?
Your response must be concise. -5.29. In the year 2001, what is the difference between the Revenue generated (in %) in Mali and Revenue generated (in %) in Sweden?
Make the answer very short. -0.58. In the year 2001, what is the difference between the Revenue generated (in %) in Mali and Revenue generated (in %) in Tunisia?
Provide a succinct answer. -8.68. In the year 2001, what is the difference between the Revenue generated (in %) in Sweden and Revenue generated (in %) in Tunisia?
Your response must be concise. -8.11. In the year 2002, what is the difference between the Revenue generated (in %) of South Asia and Revenue generated (in %) of Mali?
Your response must be concise. 2.26. In the year 2002, what is the difference between the Revenue generated (in %) of South Asia and Revenue generated (in %) of Sweden?
Provide a short and direct response. 4.42. In the year 2002, what is the difference between the Revenue generated (in %) in South Asia and Revenue generated (in %) in Tunisia?
Offer a terse response. -7.66. In the year 2002, what is the difference between the Revenue generated (in %) of Mali and Revenue generated (in %) of Sweden?
Your response must be concise. 2.16. In the year 2002, what is the difference between the Revenue generated (in %) of Mali and Revenue generated (in %) of Tunisia?
Provide a short and direct response. -9.91. In the year 2002, what is the difference between the Revenue generated (in %) of Sweden and Revenue generated (in %) of Tunisia?
Your answer should be compact. -12.08. In the year 2003, what is the difference between the Revenue generated (in %) in South Asia and Revenue generated (in %) in Mali?
Your response must be concise. 0.09. In the year 2003, what is the difference between the Revenue generated (in %) of South Asia and Revenue generated (in %) of Sweden?
Your answer should be compact. 2.93. In the year 2003, what is the difference between the Revenue generated (in %) in South Asia and Revenue generated (in %) in Tunisia?
Your answer should be compact. -8.93. In the year 2003, what is the difference between the Revenue generated (in %) of Mali and Revenue generated (in %) of Sweden?
Your answer should be very brief. 2.84. In the year 2003, what is the difference between the Revenue generated (in %) of Mali and Revenue generated (in %) of Tunisia?
Keep it short and to the point. -9.02. In the year 2003, what is the difference between the Revenue generated (in %) of Sweden and Revenue generated (in %) of Tunisia?
Make the answer very short. -11.86. In the year 2004, what is the difference between the Revenue generated (in %) of South Asia and Revenue generated (in %) of Mali?
Your response must be concise. 0.25. In the year 2004, what is the difference between the Revenue generated (in %) of South Asia and Revenue generated (in %) of Sweden?
Your answer should be compact. -0.22. In the year 2004, what is the difference between the Revenue generated (in %) of South Asia and Revenue generated (in %) of Tunisia?
Provide a succinct answer. -10.08. In the year 2004, what is the difference between the Revenue generated (in %) of Mali and Revenue generated (in %) of Sweden?
Keep it short and to the point. -0.47. In the year 2004, what is the difference between the Revenue generated (in %) in Mali and Revenue generated (in %) in Tunisia?
Your answer should be compact. -10.33. In the year 2004, what is the difference between the Revenue generated (in %) in Sweden and Revenue generated (in %) in Tunisia?
Your response must be concise. -9.86. In the year 2005, what is the difference between the Revenue generated (in %) in South Asia and Revenue generated (in %) in Mali?
Provide a short and direct response. -1.77. In the year 2005, what is the difference between the Revenue generated (in %) of South Asia and Revenue generated (in %) of Sweden?
Your answer should be very brief. -3.07. In the year 2005, what is the difference between the Revenue generated (in %) in South Asia and Revenue generated (in %) in Tunisia?
Offer a terse response. -13.45. In the year 2005, what is the difference between the Revenue generated (in %) in Mali and Revenue generated (in %) in Sweden?
Offer a terse response. -1.3. In the year 2005, what is the difference between the Revenue generated (in %) of Mali and Revenue generated (in %) of Tunisia?
Offer a very short reply. -11.68. In the year 2005, what is the difference between the Revenue generated (in %) of Sweden and Revenue generated (in %) of Tunisia?
Offer a very short reply. -10.38. In the year 2006, what is the difference between the Revenue generated (in %) of South Asia and Revenue generated (in %) of Mali?
Offer a terse response. 10.37. In the year 2006, what is the difference between the Revenue generated (in %) in South Asia and Revenue generated (in %) in Sweden?
Provide a succinct answer. -2.28. In the year 2006, what is the difference between the Revenue generated (in %) of South Asia and Revenue generated (in %) of Tunisia?
Offer a very short reply. -10.37. In the year 2006, what is the difference between the Revenue generated (in %) in Mali and Revenue generated (in %) in Sweden?
Provide a succinct answer. -12.65. In the year 2006, what is the difference between the Revenue generated (in %) of Mali and Revenue generated (in %) of Tunisia?
Give a very brief answer. -20.74. In the year 2006, what is the difference between the Revenue generated (in %) of Sweden and Revenue generated (in %) of Tunisia?
Your answer should be compact. -8.09. In the year 2007, what is the difference between the Revenue generated (in %) in South Asia and Revenue generated (in %) in Mali?
Offer a very short reply. 3.93. In the year 2007, what is the difference between the Revenue generated (in %) in South Asia and Revenue generated (in %) in Sweden?
Make the answer very short. 1.78. In the year 2007, what is the difference between the Revenue generated (in %) of South Asia and Revenue generated (in %) of Tunisia?
Provide a short and direct response. -9.79. In the year 2007, what is the difference between the Revenue generated (in %) in Mali and Revenue generated (in %) in Sweden?
Provide a succinct answer. -2.15. In the year 2007, what is the difference between the Revenue generated (in %) in Mali and Revenue generated (in %) in Tunisia?
Your answer should be compact. -13.72. In the year 2007, what is the difference between the Revenue generated (in %) in Sweden and Revenue generated (in %) in Tunisia?
Offer a very short reply. -11.57. What is the ratio of the Revenue generated (in %) of South Asia in 2000 to that in 2001?
Keep it short and to the point. 1.06. What is the ratio of the Revenue generated (in %) of Mali in 2000 to that in 2001?
Provide a succinct answer. 0.98. What is the ratio of the Revenue generated (in %) of Sweden in 2000 to that in 2001?
Make the answer very short. 1.33. What is the ratio of the Revenue generated (in %) of Tunisia in 2000 to that in 2001?
Your answer should be compact. 0.95. What is the ratio of the Revenue generated (in %) of South Asia in 2000 to that in 2002?
Ensure brevity in your answer.  1.16. What is the ratio of the Revenue generated (in %) in Mali in 2000 to that in 2002?
Offer a terse response. 1. What is the ratio of the Revenue generated (in %) of Sweden in 2000 to that in 2002?
Your answer should be very brief. 1.72. What is the ratio of the Revenue generated (in %) in Tunisia in 2000 to that in 2002?
Your response must be concise. 0.91. What is the ratio of the Revenue generated (in %) in South Asia in 2000 to that in 2003?
Give a very brief answer. 1.23. What is the ratio of the Revenue generated (in %) in Mali in 2000 to that in 2003?
Provide a short and direct response. 0.91. What is the ratio of the Revenue generated (in %) of Sweden in 2000 to that in 2003?
Your answer should be very brief. 1.62. What is the ratio of the Revenue generated (in %) in Tunisia in 2000 to that in 2003?
Offer a very short reply. 0.9. What is the ratio of the Revenue generated (in %) of South Asia in 2000 to that in 2004?
Offer a very short reply. 1.32. What is the ratio of the Revenue generated (in %) of Mali in 2000 to that in 2004?
Provide a short and direct response. 0.98. What is the ratio of the Revenue generated (in %) in Sweden in 2000 to that in 2004?
Offer a terse response. 1.34. What is the ratio of the Revenue generated (in %) in Tunisia in 2000 to that in 2004?
Offer a very short reply. 0.89. What is the ratio of the Revenue generated (in %) in South Asia in 2000 to that in 2005?
Make the answer very short. 1.34. What is the ratio of the Revenue generated (in %) in Mali in 2000 to that in 2005?
Offer a very short reply. 0.86. What is the ratio of the Revenue generated (in %) in Sweden in 2000 to that in 2005?
Make the answer very short. 1.12. What is the ratio of the Revenue generated (in %) in Tunisia in 2000 to that in 2005?
Your response must be concise. 0.78. What is the ratio of the Revenue generated (in %) in South Asia in 2000 to that in 2006?
Provide a short and direct response. 1.12. What is the ratio of the Revenue generated (in %) in Mali in 2000 to that in 2006?
Your response must be concise. 2.56. What is the ratio of the Revenue generated (in %) in Sweden in 2000 to that in 2006?
Your answer should be compact. 1.01. What is the ratio of the Revenue generated (in %) of Tunisia in 2000 to that in 2006?
Offer a very short reply. 0.8. What is the ratio of the Revenue generated (in %) in South Asia in 2000 to that in 2007?
Make the answer very short. 0.97. What is the ratio of the Revenue generated (in %) of Mali in 2000 to that in 2007?
Give a very brief answer. 0.91. What is the ratio of the Revenue generated (in %) of Sweden in 2000 to that in 2007?
Provide a short and direct response. 1.12. What is the ratio of the Revenue generated (in %) of Tunisia in 2000 to that in 2007?
Provide a short and direct response. 0.74. What is the ratio of the Revenue generated (in %) in South Asia in 2001 to that in 2002?
Ensure brevity in your answer.  1.1. What is the ratio of the Revenue generated (in %) of Mali in 2001 to that in 2002?
Keep it short and to the point. 1.02. What is the ratio of the Revenue generated (in %) of Sweden in 2001 to that in 2002?
Your response must be concise. 1.29. What is the ratio of the Revenue generated (in %) of Tunisia in 2001 to that in 2002?
Offer a terse response. 0.96. What is the ratio of the Revenue generated (in %) of South Asia in 2001 to that in 2003?
Your answer should be compact. 1.16. What is the ratio of the Revenue generated (in %) in Sweden in 2001 to that in 2003?
Provide a short and direct response. 1.22. What is the ratio of the Revenue generated (in %) in Tunisia in 2001 to that in 2003?
Your answer should be compact. 0.94. What is the ratio of the Revenue generated (in %) in South Asia in 2001 to that in 2004?
Give a very brief answer. 1.25. What is the ratio of the Revenue generated (in %) of Mali in 2001 to that in 2004?
Keep it short and to the point. 1. What is the ratio of the Revenue generated (in %) of South Asia in 2001 to that in 2005?
Your answer should be compact. 1.26. What is the ratio of the Revenue generated (in %) of Mali in 2001 to that in 2005?
Make the answer very short. 0.88. What is the ratio of the Revenue generated (in %) of Sweden in 2001 to that in 2005?
Provide a succinct answer. 0.84. What is the ratio of the Revenue generated (in %) in Tunisia in 2001 to that in 2005?
Your answer should be very brief. 0.82. What is the ratio of the Revenue generated (in %) in South Asia in 2001 to that in 2006?
Provide a short and direct response. 1.06. What is the ratio of the Revenue generated (in %) in Mali in 2001 to that in 2006?
Provide a short and direct response. 2.61. What is the ratio of the Revenue generated (in %) of Sweden in 2001 to that in 2006?
Ensure brevity in your answer.  0.76. What is the ratio of the Revenue generated (in %) in Tunisia in 2001 to that in 2006?
Your response must be concise. 0.84. What is the ratio of the Revenue generated (in %) of South Asia in 2001 to that in 2007?
Provide a short and direct response. 0.91. What is the ratio of the Revenue generated (in %) in Mali in 2001 to that in 2007?
Give a very brief answer. 0.93. What is the ratio of the Revenue generated (in %) in Sweden in 2001 to that in 2007?
Provide a short and direct response. 0.84. What is the ratio of the Revenue generated (in %) of Tunisia in 2001 to that in 2007?
Your answer should be very brief. 0.78. What is the ratio of the Revenue generated (in %) of South Asia in 2002 to that in 2003?
Provide a short and direct response. 1.06. What is the ratio of the Revenue generated (in %) of Mali in 2002 to that in 2003?
Your answer should be very brief. 0.9. What is the ratio of the Revenue generated (in %) in Sweden in 2002 to that in 2003?
Ensure brevity in your answer.  0.94. What is the ratio of the Revenue generated (in %) in Tunisia in 2002 to that in 2003?
Give a very brief answer. 0.98. What is the ratio of the Revenue generated (in %) in South Asia in 2002 to that in 2004?
Your answer should be compact. 1.14. What is the ratio of the Revenue generated (in %) of Mali in 2002 to that in 2004?
Your answer should be compact. 0.98. What is the ratio of the Revenue generated (in %) in Sweden in 2002 to that in 2004?
Give a very brief answer. 0.78. What is the ratio of the Revenue generated (in %) of Tunisia in 2002 to that in 2004?
Your response must be concise. 0.97. What is the ratio of the Revenue generated (in %) in South Asia in 2002 to that in 2005?
Ensure brevity in your answer.  1.15. What is the ratio of the Revenue generated (in %) of Mali in 2002 to that in 2005?
Give a very brief answer. 0.86. What is the ratio of the Revenue generated (in %) in Sweden in 2002 to that in 2005?
Provide a succinct answer. 0.65. What is the ratio of the Revenue generated (in %) in Tunisia in 2002 to that in 2005?
Your response must be concise. 0.85. What is the ratio of the Revenue generated (in %) in South Asia in 2002 to that in 2006?
Ensure brevity in your answer.  0.96. What is the ratio of the Revenue generated (in %) in Mali in 2002 to that in 2006?
Make the answer very short. 2.55. What is the ratio of the Revenue generated (in %) of Sweden in 2002 to that in 2006?
Keep it short and to the point. 0.59. What is the ratio of the Revenue generated (in %) in Tunisia in 2002 to that in 2006?
Offer a terse response. 0.87. What is the ratio of the Revenue generated (in %) of South Asia in 2002 to that in 2007?
Your response must be concise. 0.83. What is the ratio of the Revenue generated (in %) in Mali in 2002 to that in 2007?
Your response must be concise. 0.91. What is the ratio of the Revenue generated (in %) of Sweden in 2002 to that in 2007?
Keep it short and to the point. 0.65. What is the ratio of the Revenue generated (in %) in Tunisia in 2002 to that in 2007?
Your answer should be very brief. 0.81. What is the ratio of the Revenue generated (in %) in South Asia in 2003 to that in 2004?
Provide a succinct answer. 1.07. What is the ratio of the Revenue generated (in %) in Mali in 2003 to that in 2004?
Provide a succinct answer. 1.09. What is the ratio of the Revenue generated (in %) in Sweden in 2003 to that in 2004?
Give a very brief answer. 0.83. What is the ratio of the Revenue generated (in %) of Tunisia in 2003 to that in 2004?
Provide a short and direct response. 0.99. What is the ratio of the Revenue generated (in %) of South Asia in 2003 to that in 2005?
Offer a terse response. 1.09. What is the ratio of the Revenue generated (in %) in Mali in 2003 to that in 2005?
Keep it short and to the point. 0.95. What is the ratio of the Revenue generated (in %) of Sweden in 2003 to that in 2005?
Your response must be concise. 0.69. What is the ratio of the Revenue generated (in %) in Tunisia in 2003 to that in 2005?
Ensure brevity in your answer.  0.87. What is the ratio of the Revenue generated (in %) in South Asia in 2003 to that in 2006?
Provide a short and direct response. 0.91. What is the ratio of the Revenue generated (in %) of Mali in 2003 to that in 2006?
Make the answer very short. 2.83. What is the ratio of the Revenue generated (in %) in Sweden in 2003 to that in 2006?
Give a very brief answer. 0.62. What is the ratio of the Revenue generated (in %) in Tunisia in 2003 to that in 2006?
Your answer should be compact. 0.89. What is the ratio of the Revenue generated (in %) in South Asia in 2003 to that in 2007?
Your response must be concise. 0.79. What is the ratio of the Revenue generated (in %) of Sweden in 2003 to that in 2007?
Keep it short and to the point. 0.69. What is the ratio of the Revenue generated (in %) in Tunisia in 2003 to that in 2007?
Your answer should be very brief. 0.83. What is the ratio of the Revenue generated (in %) in South Asia in 2004 to that in 2005?
Ensure brevity in your answer.  1.01. What is the ratio of the Revenue generated (in %) of Mali in 2004 to that in 2005?
Give a very brief answer. 0.87. What is the ratio of the Revenue generated (in %) of Sweden in 2004 to that in 2005?
Make the answer very short. 0.83. What is the ratio of the Revenue generated (in %) in Tunisia in 2004 to that in 2005?
Ensure brevity in your answer.  0.88. What is the ratio of the Revenue generated (in %) of South Asia in 2004 to that in 2006?
Make the answer very short. 0.85. What is the ratio of the Revenue generated (in %) in Mali in 2004 to that in 2006?
Provide a succinct answer. 2.6. What is the ratio of the Revenue generated (in %) of Sweden in 2004 to that in 2006?
Your answer should be compact. 0.75. What is the ratio of the Revenue generated (in %) of Tunisia in 2004 to that in 2006?
Your response must be concise. 0.9. What is the ratio of the Revenue generated (in %) in South Asia in 2004 to that in 2007?
Your response must be concise. 0.73. What is the ratio of the Revenue generated (in %) in Mali in 2004 to that in 2007?
Ensure brevity in your answer.  0.93. What is the ratio of the Revenue generated (in %) in Sweden in 2004 to that in 2007?
Provide a succinct answer. 0.83. What is the ratio of the Revenue generated (in %) of Tunisia in 2004 to that in 2007?
Provide a succinct answer. 0.84. What is the ratio of the Revenue generated (in %) of South Asia in 2005 to that in 2006?
Offer a terse response. 0.84. What is the ratio of the Revenue generated (in %) in Mali in 2005 to that in 2006?
Offer a terse response. 2.98. What is the ratio of the Revenue generated (in %) in Sweden in 2005 to that in 2006?
Ensure brevity in your answer.  0.9. What is the ratio of the Revenue generated (in %) in Tunisia in 2005 to that in 2006?
Offer a very short reply. 1.02. What is the ratio of the Revenue generated (in %) in South Asia in 2005 to that in 2007?
Your answer should be very brief. 0.72. What is the ratio of the Revenue generated (in %) of Mali in 2005 to that in 2007?
Give a very brief answer. 1.06. What is the ratio of the Revenue generated (in %) of Sweden in 2005 to that in 2007?
Give a very brief answer. 1. What is the ratio of the Revenue generated (in %) in Tunisia in 2005 to that in 2007?
Your response must be concise. 0.96. What is the ratio of the Revenue generated (in %) in South Asia in 2006 to that in 2007?
Offer a terse response. 0.86. What is the ratio of the Revenue generated (in %) of Mali in 2006 to that in 2007?
Keep it short and to the point. 0.36. What is the ratio of the Revenue generated (in %) of Sweden in 2006 to that in 2007?
Your answer should be compact. 1.11. What is the ratio of the Revenue generated (in %) of Tunisia in 2006 to that in 2007?
Your answer should be very brief. 0.93. What is the difference between the highest and the second highest Revenue generated (in %) of South Asia?
Offer a terse response. 0.54. What is the difference between the highest and the second highest Revenue generated (in %) of Mali?
Provide a short and direct response. 0.74. What is the difference between the highest and the second highest Revenue generated (in %) in Sweden?
Your answer should be compact. 0.16. What is the difference between the highest and the second highest Revenue generated (in %) in Tunisia?
Provide a succinct answer. 1.22. What is the difference between the highest and the lowest Revenue generated (in %) in South Asia?
Your response must be concise. 4.88. What is the difference between the highest and the lowest Revenue generated (in %) in Mali?
Ensure brevity in your answer.  9.64. What is the difference between the highest and the lowest Revenue generated (in %) in Sweden?
Offer a very short reply. 7.41. What is the difference between the highest and the lowest Revenue generated (in %) in Tunisia?
Provide a succinct answer. 7.01. 